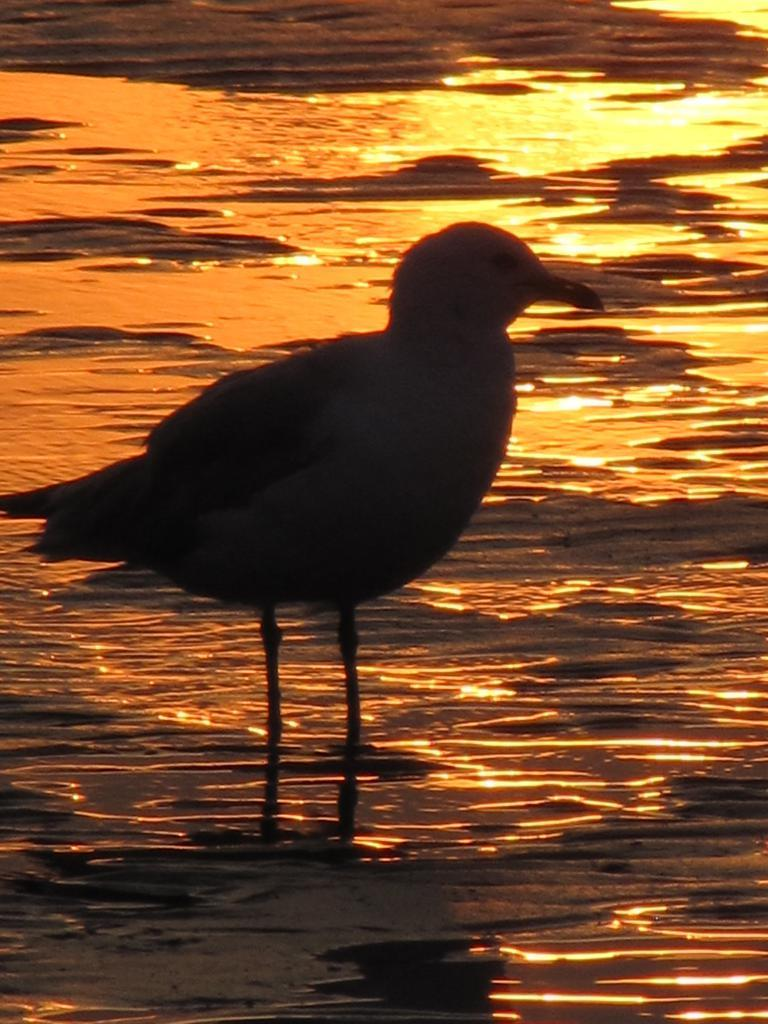What type of animal can be seen in the image? There is a bird in the image. What is the primary element in which the bird is situated? There is water visible in the image, and the bird is situated in it. What type of spy equipment can be seen in the image? There is no spy equipment present in the image; it features a bird in water. How does the bird's breath affect the water in the image? The image does not show the bird's breath, so it cannot be determined how it might affect the water. 